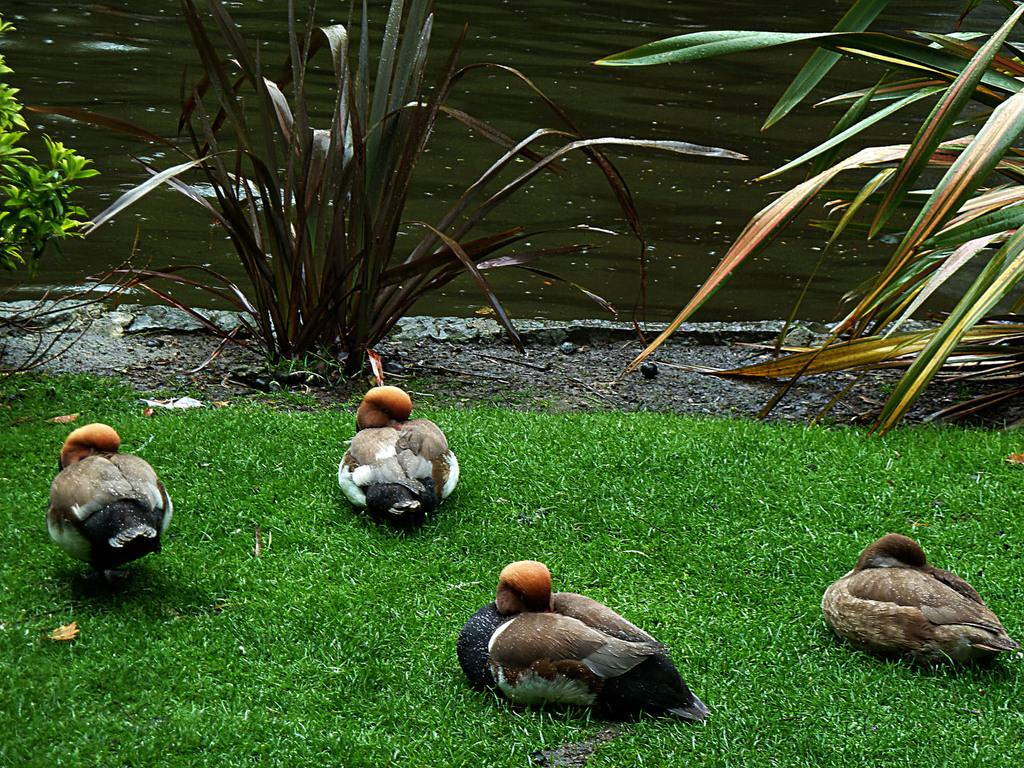What type of animals can be seen in the image? Birds can be seen in the image. What type of vegetation is present in the image? There is grass and plants visible in the image. What can be seen in the background of the image? There is a river visible in the background of the image. What is the chance of winning a baseball game in the image? There is no reference to a baseball game or any sports event in the image, so it's not possible to determine the chance of winning a game. 